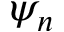Convert formula to latex. <formula><loc_0><loc_0><loc_500><loc_500>\psi _ { n }</formula> 